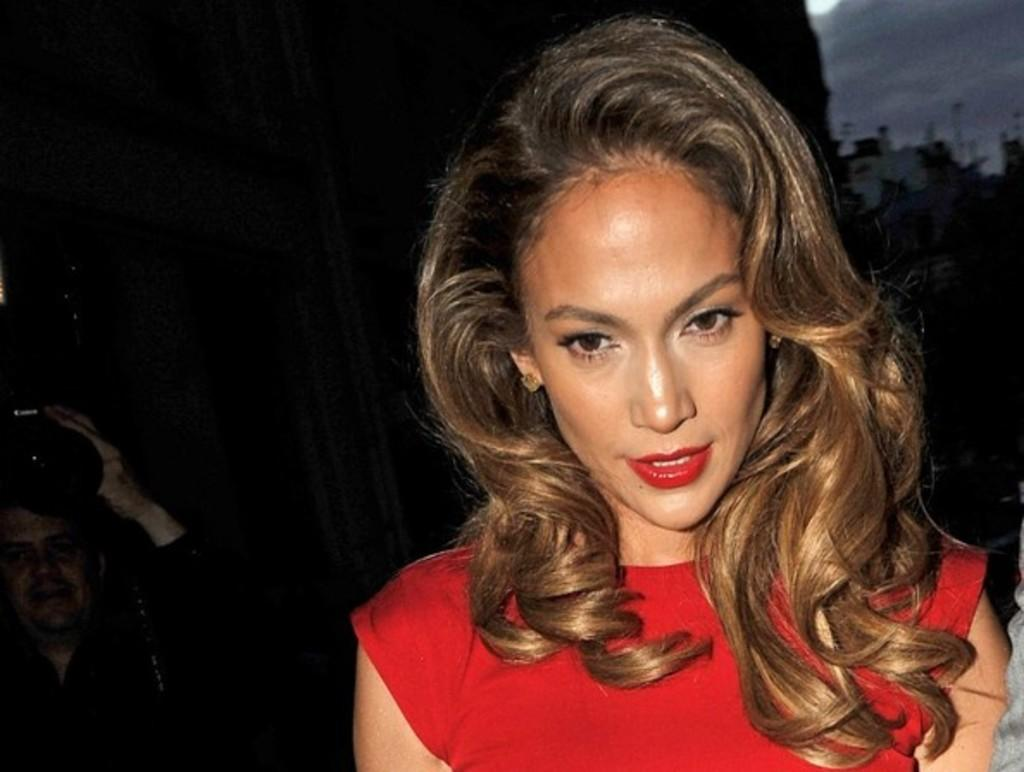Who are the people in the image? There is a woman and a man in the image. What is the man holding in the image? The man is holding a camera in the image. How would you describe the background of the image? The background of the image is dark. How many sheep can be seen in the image? There are no sheep present in the image. What type of bed is visible in the image? There is no bed present in the image. 